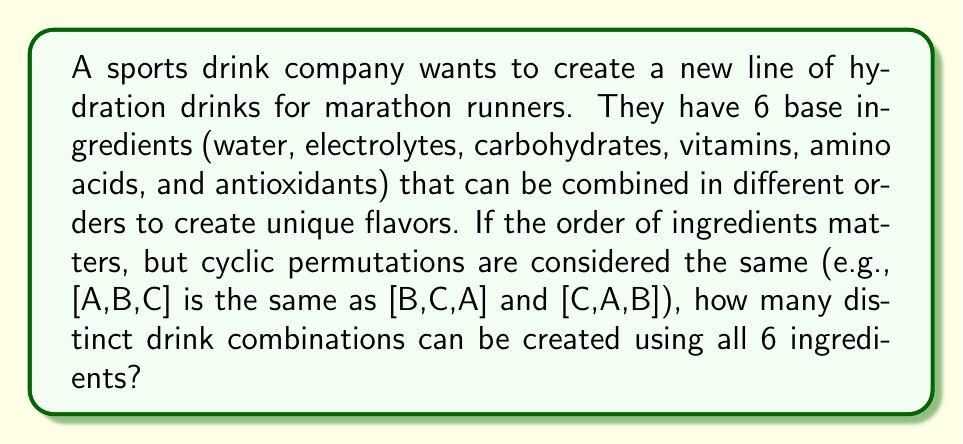Give your solution to this math problem. To solve this problem, we need to use the concept of cyclic groups from Ring theory. Here's a step-by-step explanation:

1) First, we need to calculate the total number of permutations of 6 ingredients:
   $$6! = 6 \times 5 \times 4 \times 3 \times 2 \times 1 = 720$$

2) However, in cyclic groups, rotations of the same arrangement are considered identical. For example, [A,B,C,D,E,F], [B,C,D,E,F,A], [C,D,E,F,A,B], etc., are all considered the same combination.

3) The number of rotations for each arrangement is equal to the number of ingredients, which is 6 in this case.

4) Therefore, to find the number of unique combinations, we need to divide the total number of permutations by the number of rotations:

   $$\text{Number of unique combinations} = \frac{\text{Total permutations}}{\text{Number of rotations}} = \frac{6!}{6} = \frac{720}{6} = 120$$

5) This result can also be derived from the formula for the number of elements in a cyclic group of order n, which is $(n-1)!$:

   $$(6-1)! = 5! = 5 \times 4 \times 3 \times 2 \times 1 = 120$$

Thus, there are 120 distinct drink combinations when considering cyclic permutations as equivalent.
Answer: 120 distinct drink combinations 